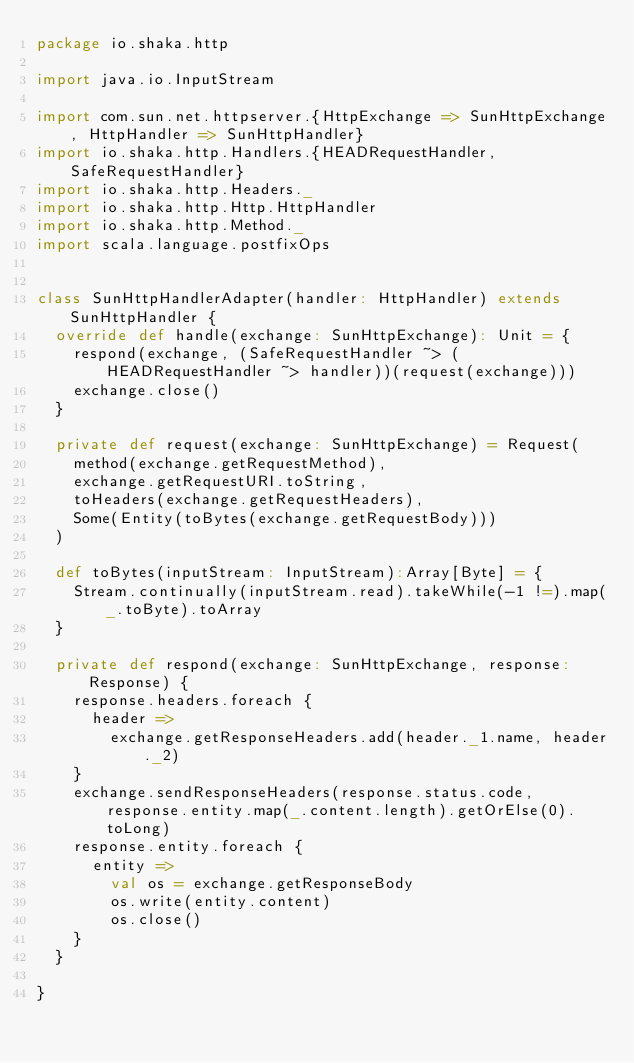<code> <loc_0><loc_0><loc_500><loc_500><_Scala_>package io.shaka.http

import java.io.InputStream

import com.sun.net.httpserver.{HttpExchange => SunHttpExchange, HttpHandler => SunHttpHandler}
import io.shaka.http.Handlers.{HEADRequestHandler, SafeRequestHandler}
import io.shaka.http.Headers._
import io.shaka.http.Http.HttpHandler
import io.shaka.http.Method._
import scala.language.postfixOps


class SunHttpHandlerAdapter(handler: HttpHandler) extends SunHttpHandler {
  override def handle(exchange: SunHttpExchange): Unit = {
    respond(exchange, (SafeRequestHandler ~> (HEADRequestHandler ~> handler))(request(exchange)))
    exchange.close()
  }

  private def request(exchange: SunHttpExchange) = Request(
    method(exchange.getRequestMethod),
    exchange.getRequestURI.toString,
    toHeaders(exchange.getRequestHeaders),
    Some(Entity(toBytes(exchange.getRequestBody)))
  )

  def toBytes(inputStream: InputStream):Array[Byte] = {
    Stream.continually(inputStream.read).takeWhile(-1 !=).map(_.toByte).toArray
  }

  private def respond(exchange: SunHttpExchange, response: Response) {
    response.headers.foreach {
      header =>
        exchange.getResponseHeaders.add(header._1.name, header._2)
    }
    exchange.sendResponseHeaders(response.status.code, response.entity.map(_.content.length).getOrElse(0).toLong)
    response.entity.foreach {
      entity =>
        val os = exchange.getResponseBody
        os.write(entity.content)
        os.close()
    }
  }

}



</code> 